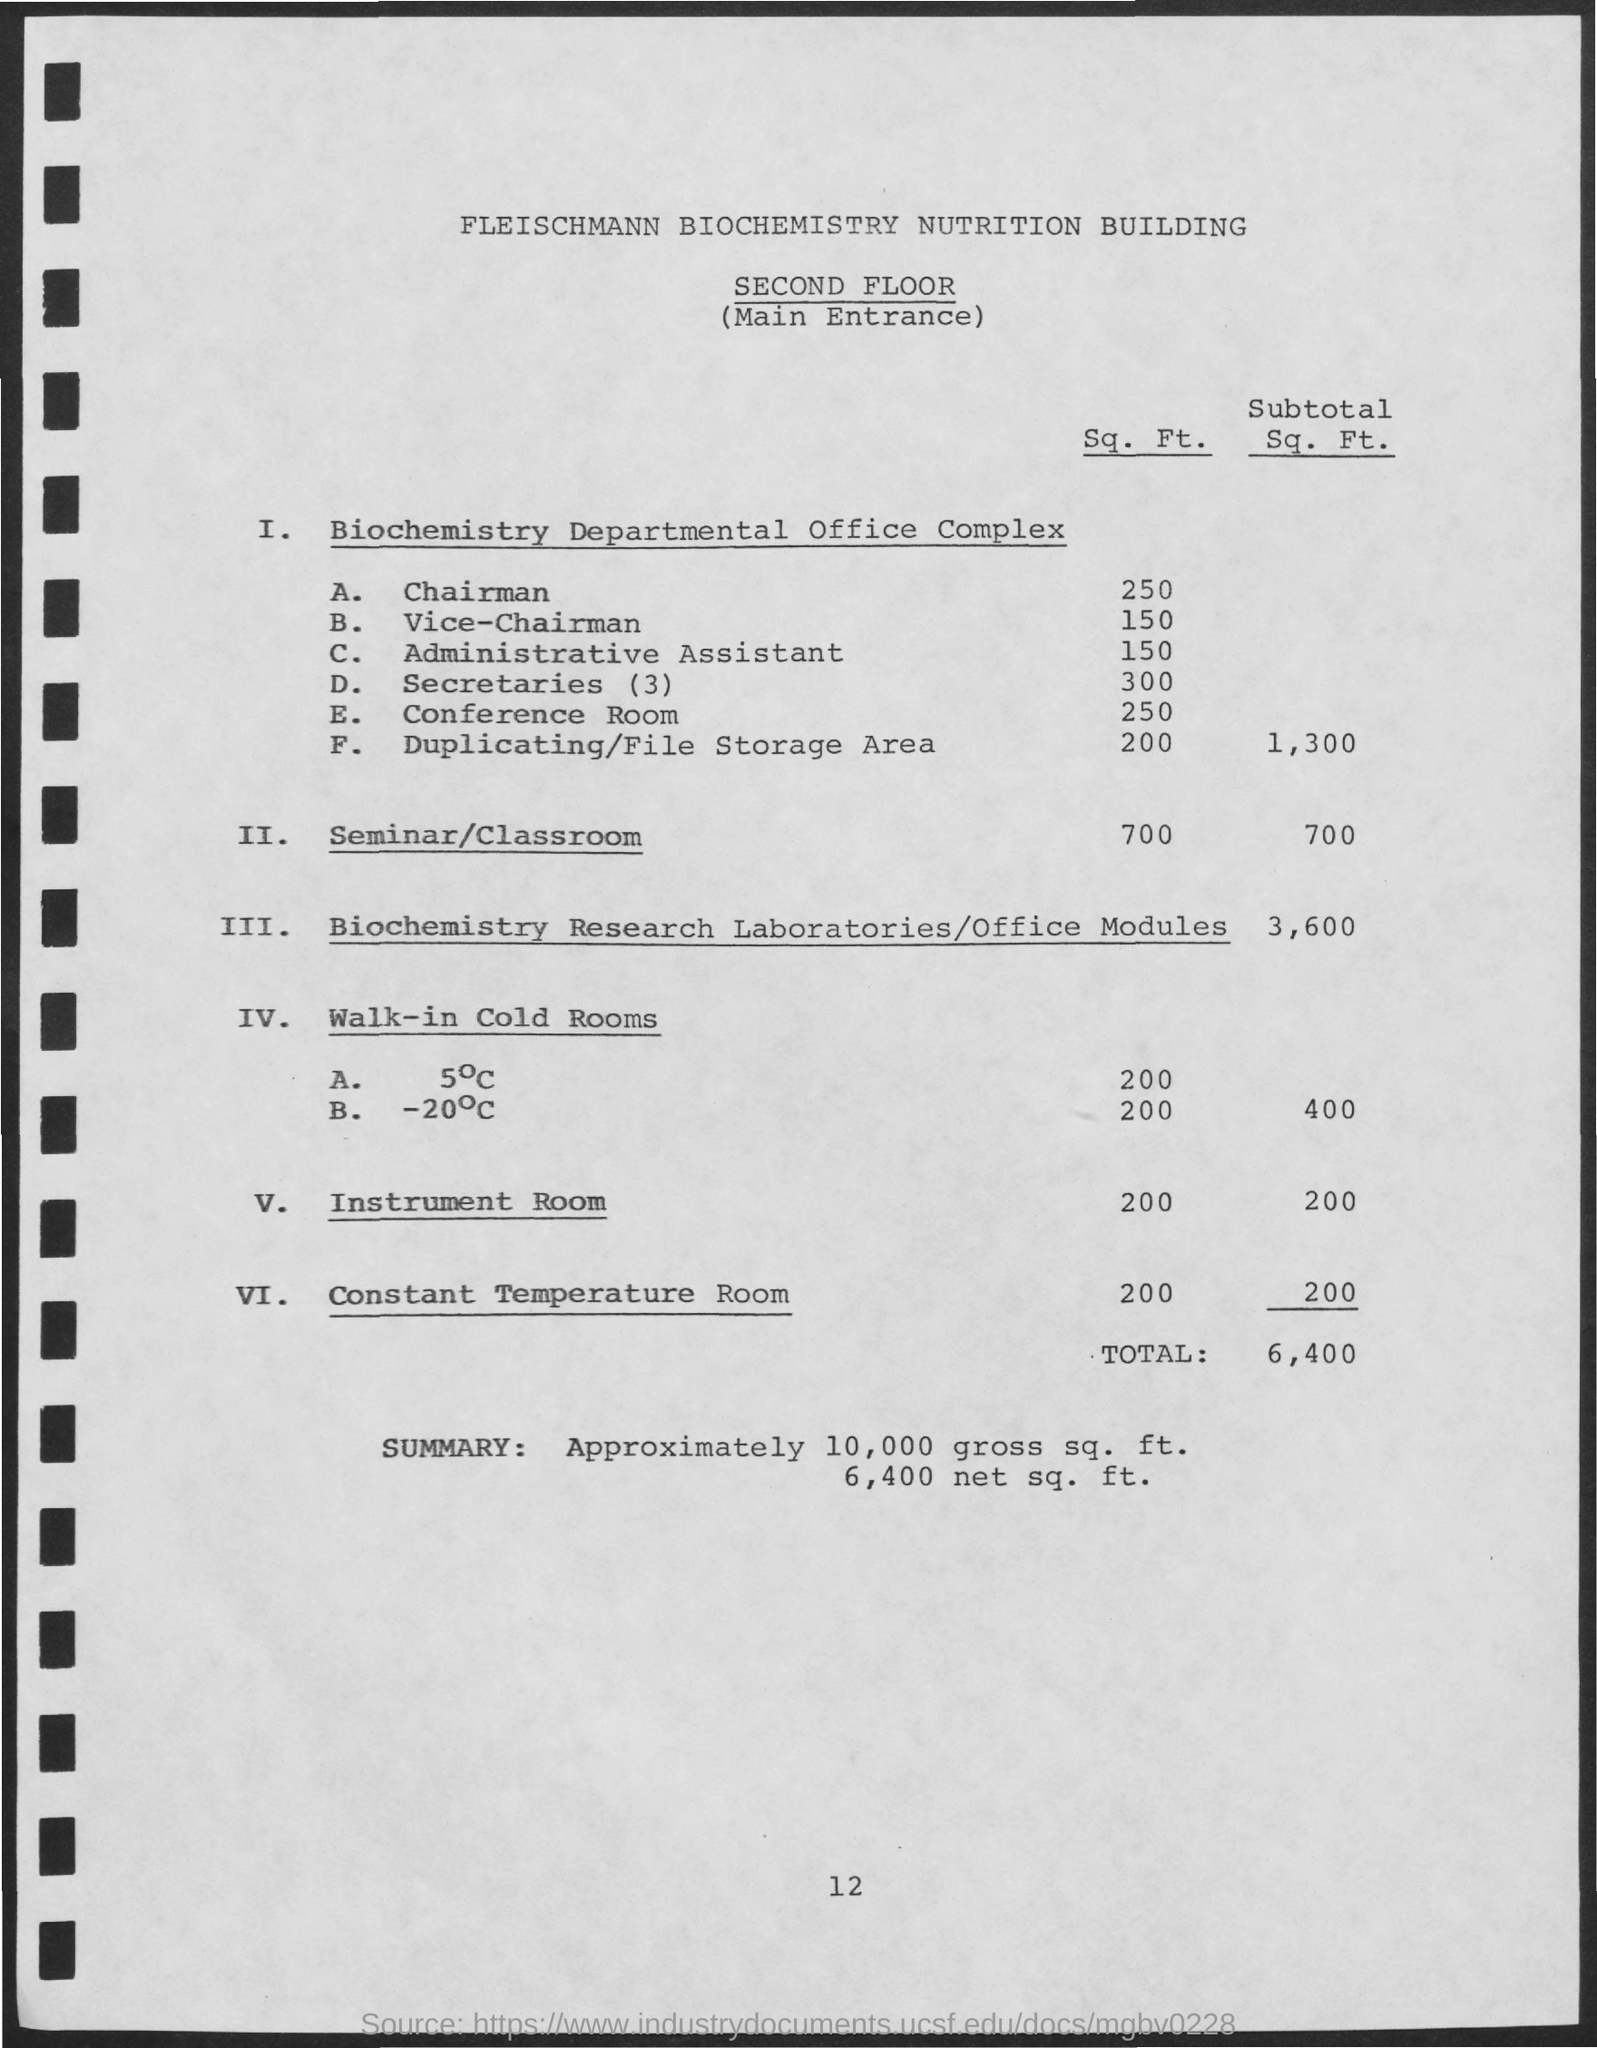Draw attention to some important aspects in this diagram. The square footage of the seminar/classroom mentioned is 700 square feet. The subtotal square footage value of biochemistry research laboratories and office modules is 3,600. The square footage of the instrument room mentioned is 200 square feet. The total value mentioned is approximately 6,400. 